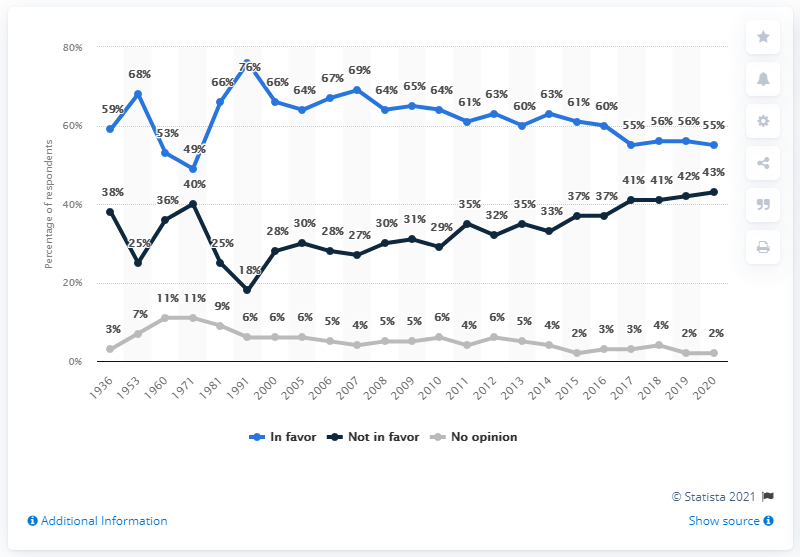Mention a couple of crucial points in this snapshot. In the year 1971, there was a difference between those who favored and those who did not favor the death penalty. In 2020, 55% of people favored the death penalty. 